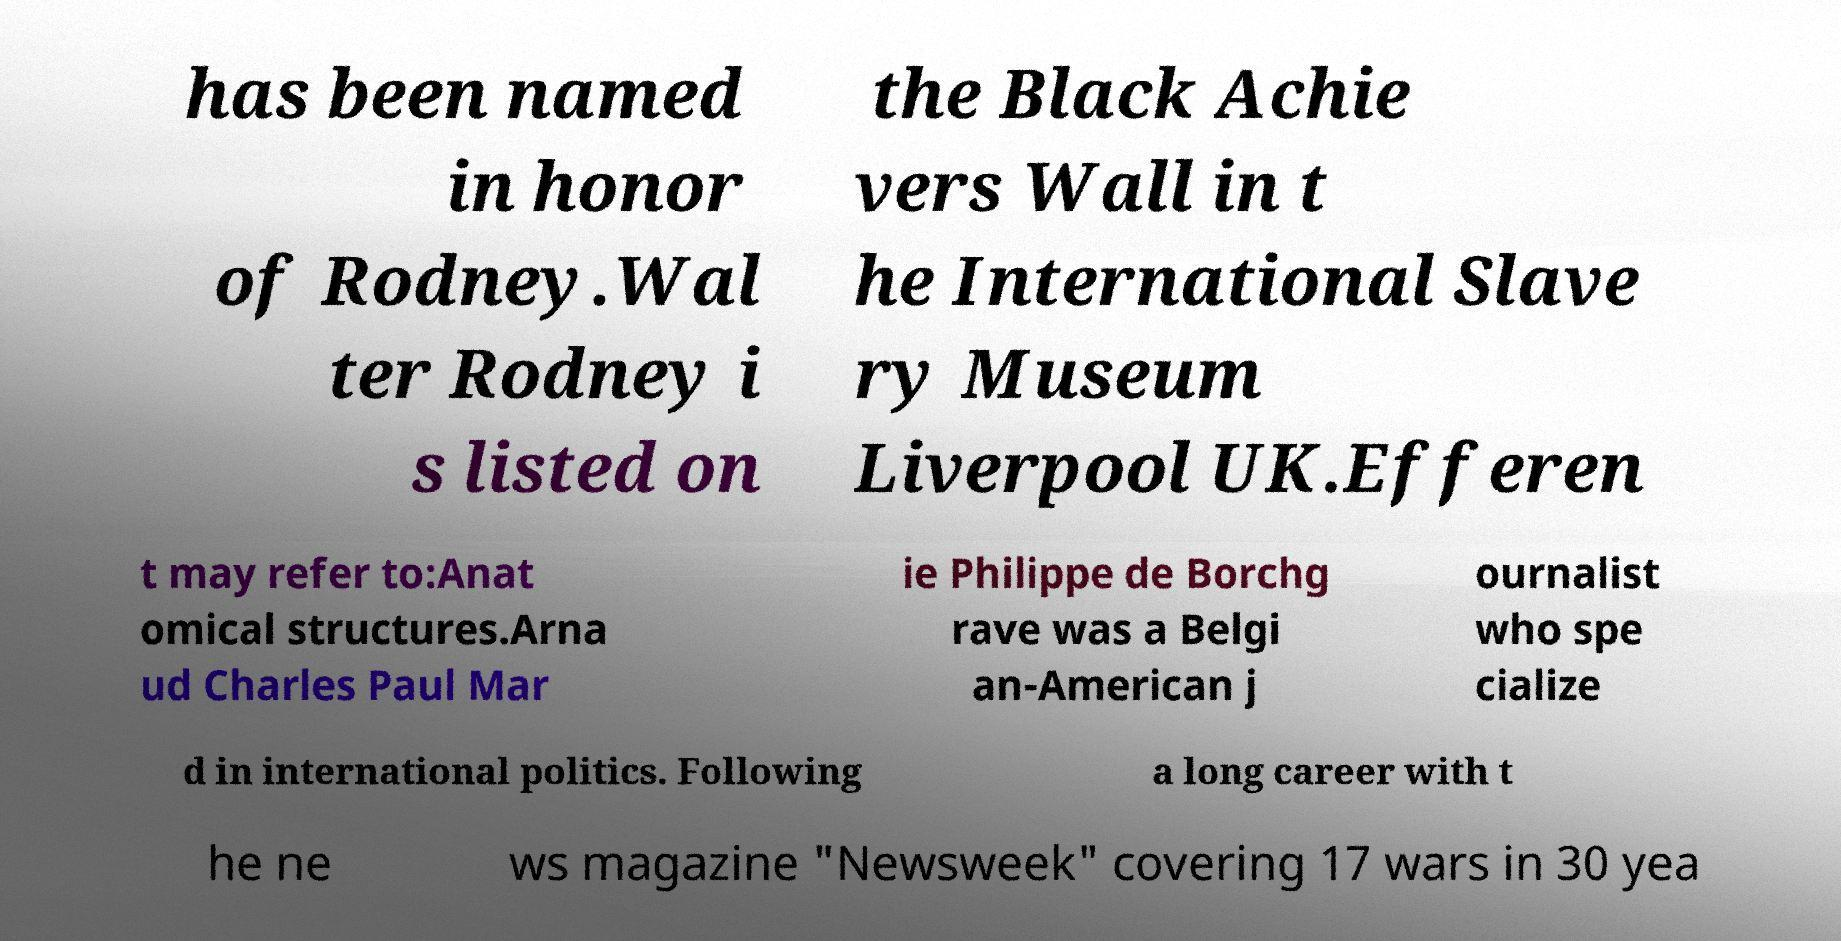What messages or text are displayed in this image? I need them in a readable, typed format. has been named in honor of Rodney.Wal ter Rodney i s listed on the Black Achie vers Wall in t he International Slave ry Museum Liverpool UK.Efferen t may refer to:Anat omical structures.Arna ud Charles Paul Mar ie Philippe de Borchg rave was a Belgi an-American j ournalist who spe cialize d in international politics. Following a long career with t he ne ws magazine "Newsweek" covering 17 wars in 30 yea 